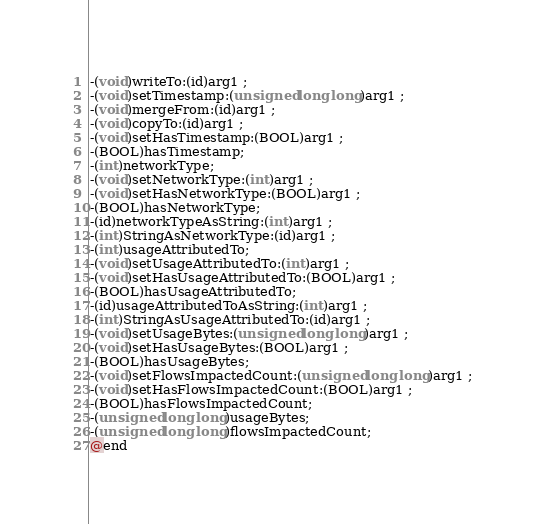<code> <loc_0><loc_0><loc_500><loc_500><_C_>-(void)writeTo:(id)arg1 ;
-(void)setTimestamp:(unsigned long long)arg1 ;
-(void)mergeFrom:(id)arg1 ;
-(void)copyTo:(id)arg1 ;
-(void)setHasTimestamp:(BOOL)arg1 ;
-(BOOL)hasTimestamp;
-(int)networkType;
-(void)setNetworkType:(int)arg1 ;
-(void)setHasNetworkType:(BOOL)arg1 ;
-(BOOL)hasNetworkType;
-(id)networkTypeAsString:(int)arg1 ;
-(int)StringAsNetworkType:(id)arg1 ;
-(int)usageAttributedTo;
-(void)setUsageAttributedTo:(int)arg1 ;
-(void)setHasUsageAttributedTo:(BOOL)arg1 ;
-(BOOL)hasUsageAttributedTo;
-(id)usageAttributedToAsString:(int)arg1 ;
-(int)StringAsUsageAttributedTo:(id)arg1 ;
-(void)setUsageBytes:(unsigned long long)arg1 ;
-(void)setHasUsageBytes:(BOOL)arg1 ;
-(BOOL)hasUsageBytes;
-(void)setFlowsImpactedCount:(unsigned long long)arg1 ;
-(void)setHasFlowsImpactedCount:(BOOL)arg1 ;
-(BOOL)hasFlowsImpactedCount;
-(unsigned long long)usageBytes;
-(unsigned long long)flowsImpactedCount;
@end

</code> 